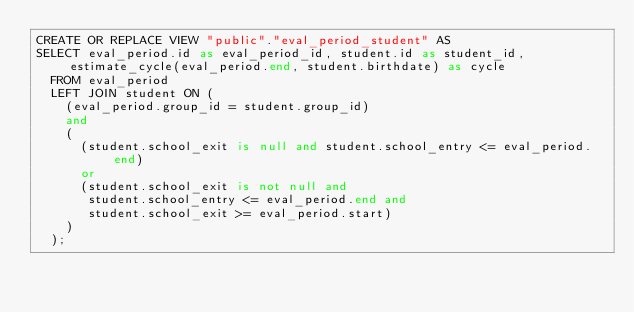<code> <loc_0><loc_0><loc_500><loc_500><_SQL_>CREATE OR REPLACE VIEW "public"."eval_period_student" AS
SELECT eval_period.id as eval_period_id, student.id as student_id, estimate_cycle(eval_period.end, student.birthdate) as cycle
  FROM eval_period
  LEFT JOIN student ON (
    (eval_period.group_id = student.group_id)
    and
    (
      (student.school_exit is null and student.school_entry <= eval_period.end)
      or
      (student.school_exit is not null and
       student.school_entry <= eval_period.end and
       student.school_exit >= eval_period.start)
    )
  );
</code> 